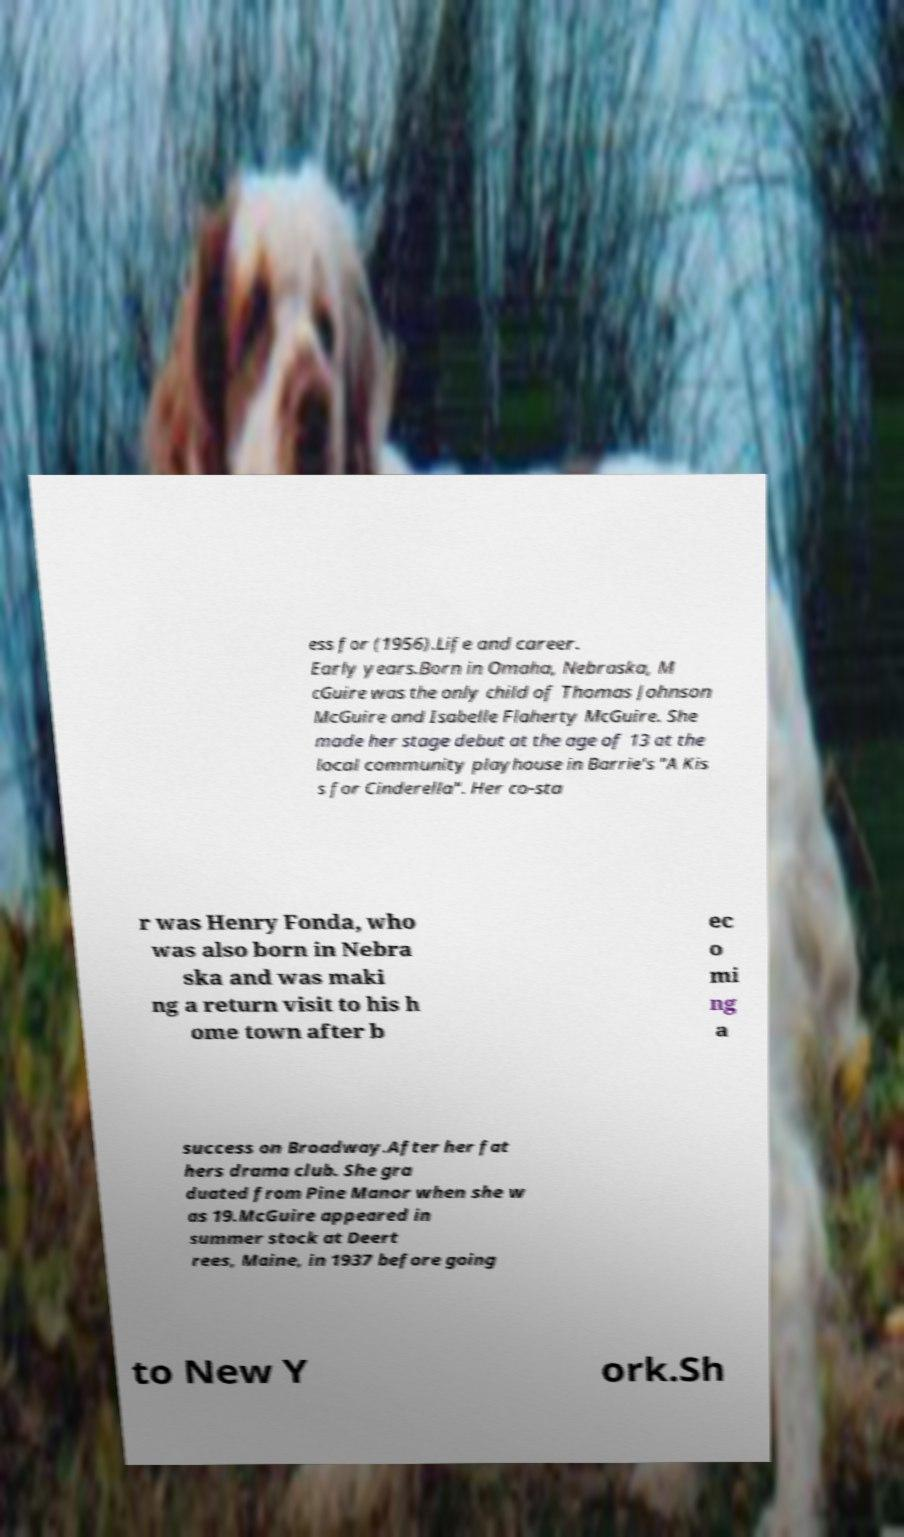Can you read and provide the text displayed in the image?This photo seems to have some interesting text. Can you extract and type it out for me? ess for (1956).Life and career. Early years.Born in Omaha, Nebraska, M cGuire was the only child of Thomas Johnson McGuire and Isabelle Flaherty McGuire. She made her stage debut at the age of 13 at the local community playhouse in Barrie's "A Kis s for Cinderella". Her co-sta r was Henry Fonda, who was also born in Nebra ska and was maki ng a return visit to his h ome town after b ec o mi ng a success on Broadway.After her fat hers drama club. She gra duated from Pine Manor when she w as 19.McGuire appeared in summer stock at Deert rees, Maine, in 1937 before going to New Y ork.Sh 